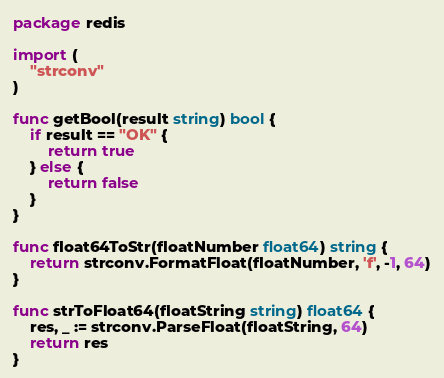Convert code to text. <code><loc_0><loc_0><loc_500><loc_500><_Go_>package redis

import (
	"strconv"
)

func getBool(result string) bool {
	if result == "OK" {
		return true
	} else {
		return false
	}
}

func float64ToStr(floatNumber float64) string {
	return strconv.FormatFloat(floatNumber, 'f', -1, 64)
}

func strToFloat64(floatString string) float64 {
	res, _ := strconv.ParseFloat(floatString, 64)
	return res
}
</code> 